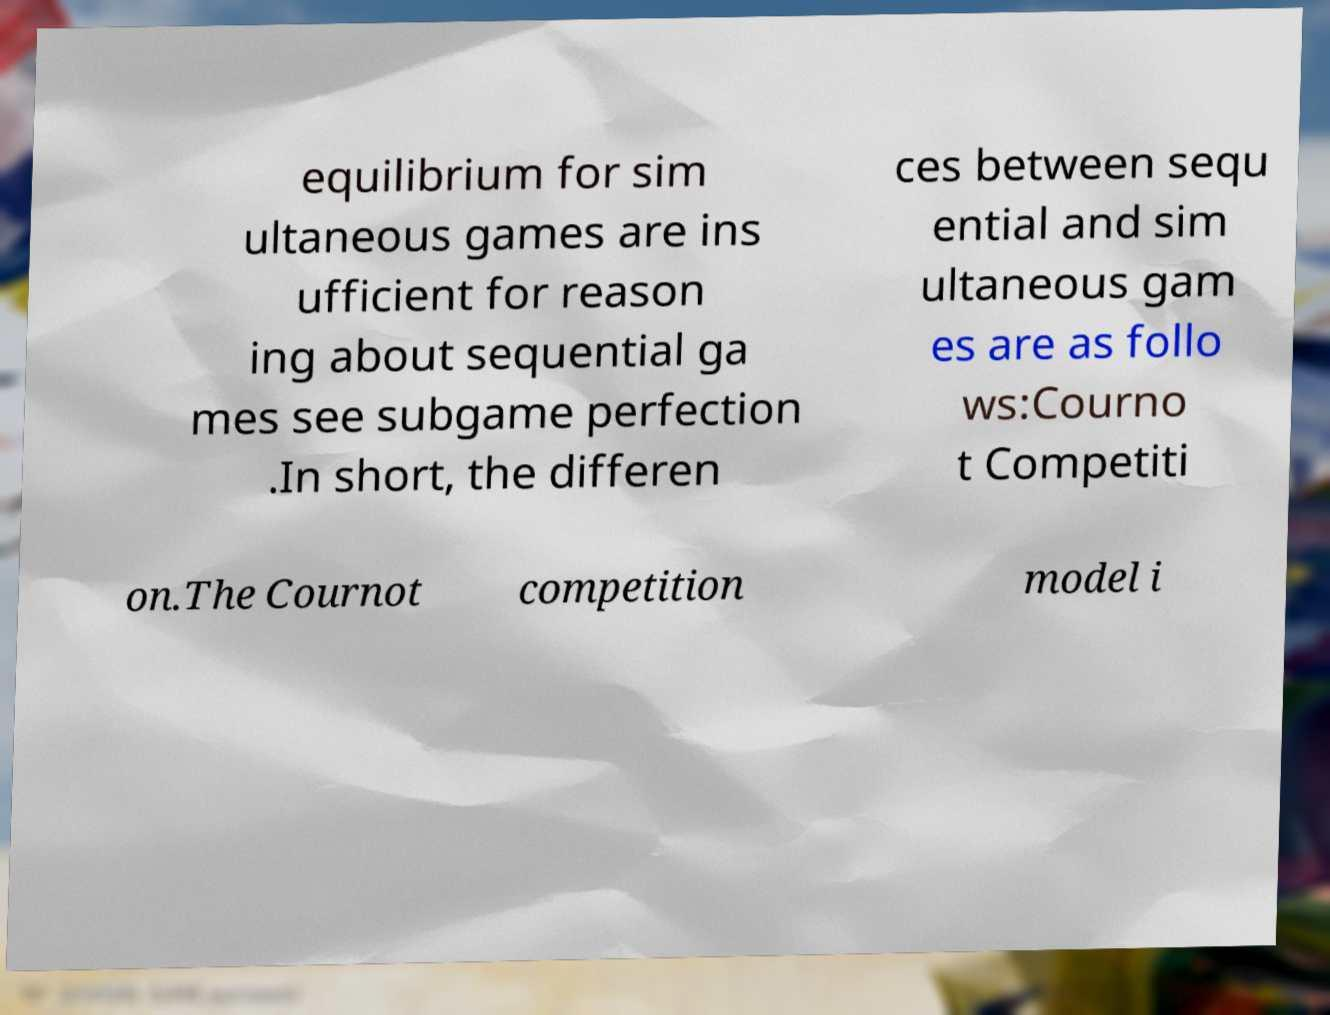Can you read and provide the text displayed in the image?This photo seems to have some interesting text. Can you extract and type it out for me? equilibrium for sim ultaneous games are ins ufficient for reason ing about sequential ga mes see subgame perfection .In short, the differen ces between sequ ential and sim ultaneous gam es are as follo ws:Courno t Competiti on.The Cournot competition model i 